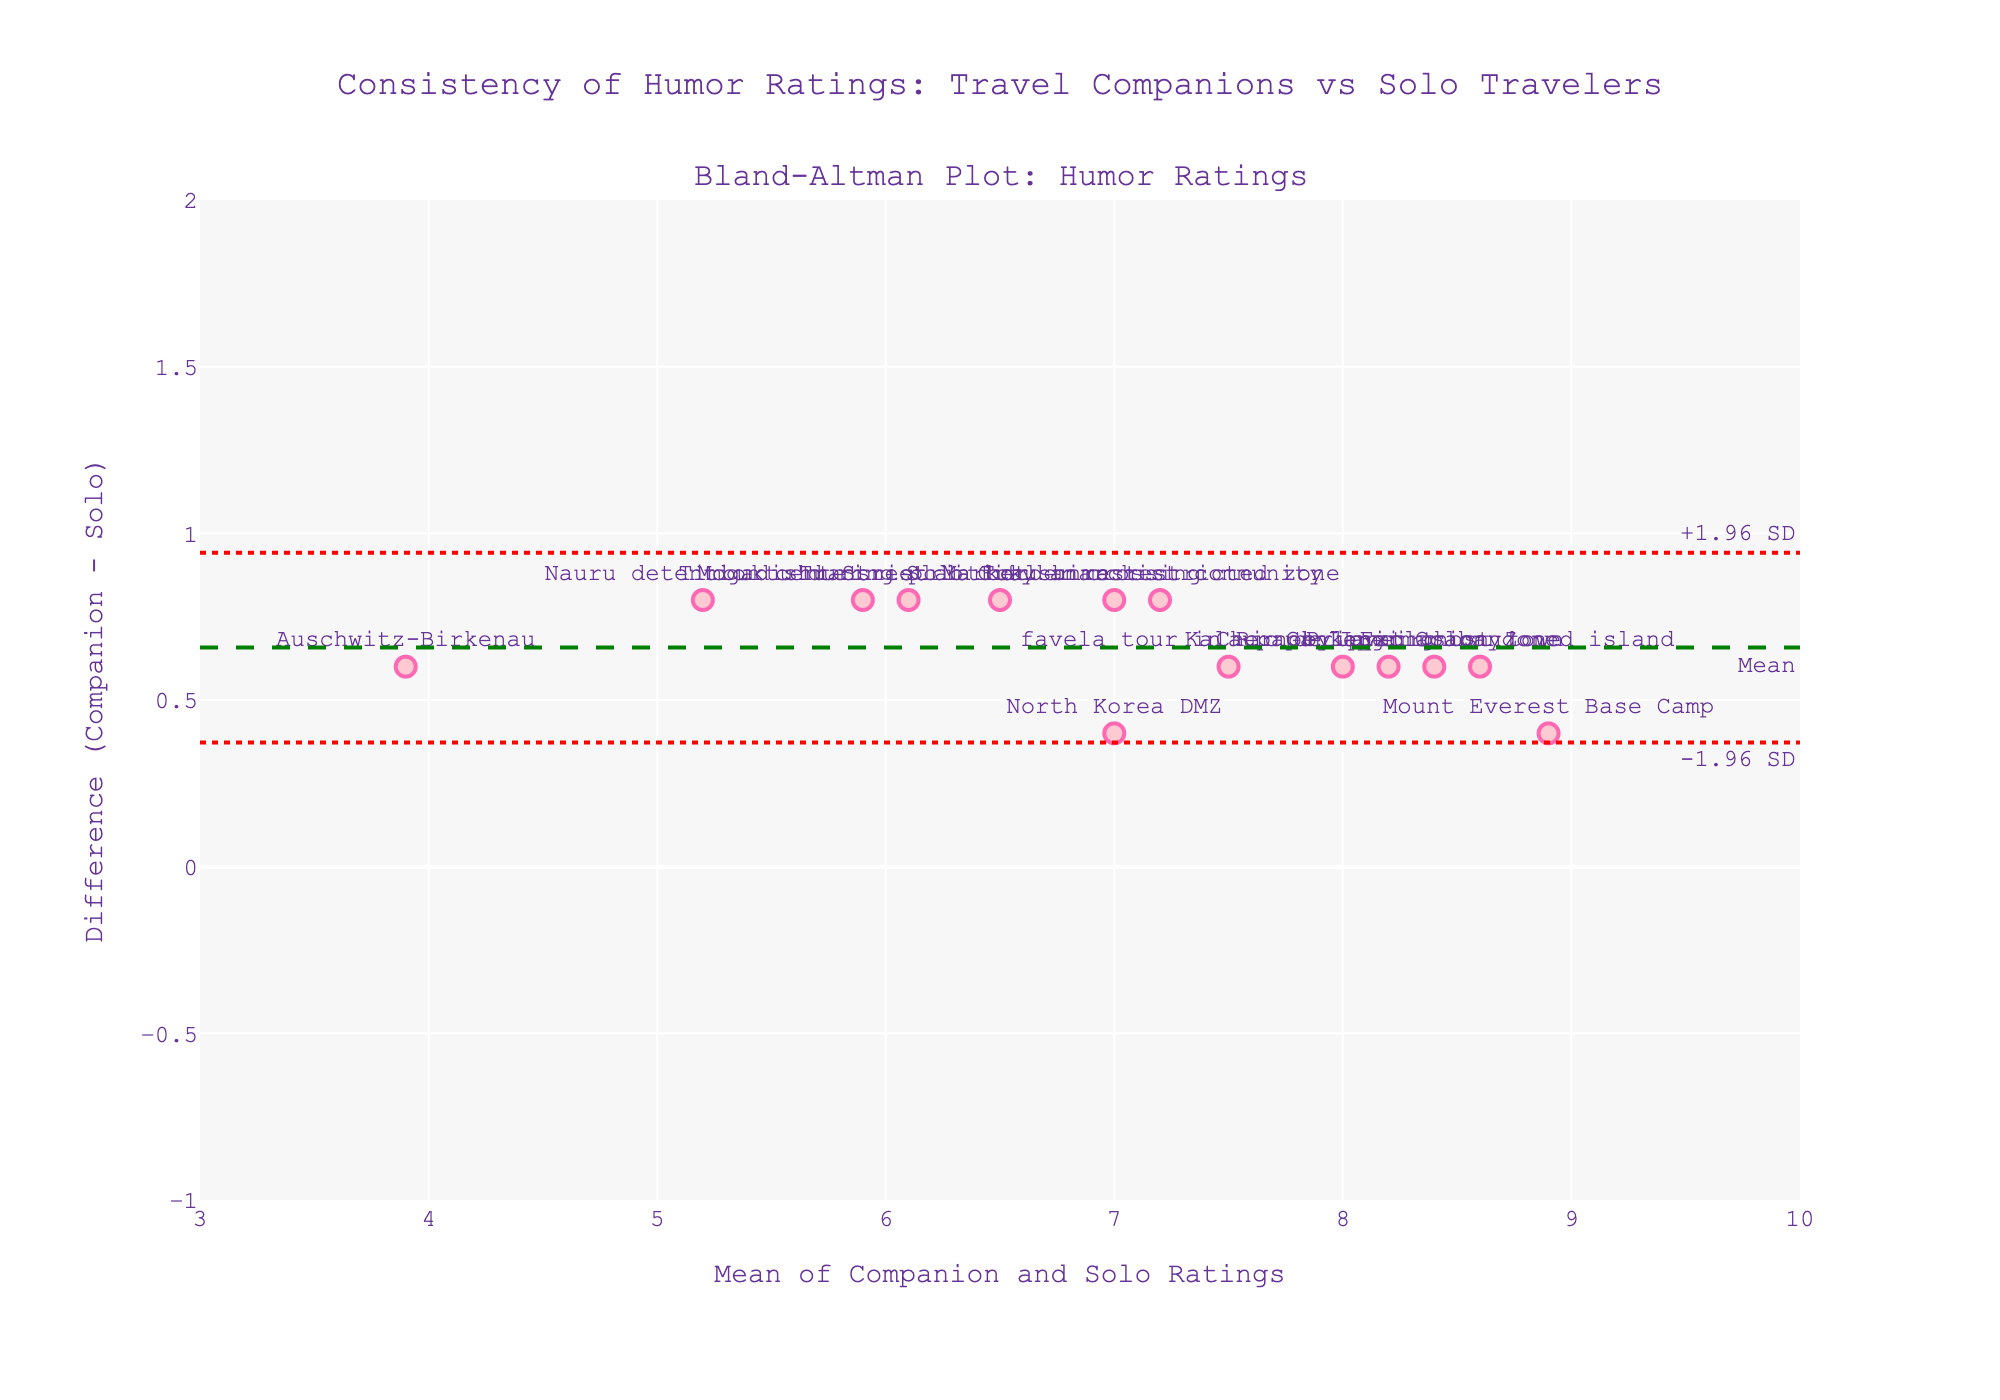what is the title of the figure? The title of the figure is displayed at the top of the plot. It reads "Consistency of Humor Ratings: Travel Companions vs Solo Travelers."
Answer: Consistency of Humor Ratings: Travel Companions vs Solo Travelers How many data points are plotted in the figure? Each marker on the plot represents a data point for a travel destination. By counting the markers, we see there are 14 data points.
Answer: 14 Which travel destination has the largest positive difference in humor ratings between companions and solo travelers? The largest positive difference is identified by the highest y-value on the plot. Checking the y-axis, "Gunkanjima abandoned island" appears to have the largest positive difference at approximately +0.6.
Answer: Gunkanjima abandoned island What are the limits of agreement in the plot? The limits of agreement are represented by the two dotted red lines. The annotations show that they are at approximately -0.19 (lower limit) and +1.27 (upper limit).
Answer: -0.19 and +1.27 Is the mean difference between Companion and Solo Ratings positive or negative? The mean difference is indicated by the green dashed line labeled "Mean." It is positioned above the zero line on the y-axis, indicating a positive mean difference.
Answer: Positive Are there any data points outside the limits of agreement? If so, which one(s)? Data points outside the red dotted lines are outside the limits of agreement. Observing the plot, there's at least one such point: "Auschwitz-Birkenau."
Answer: Auschwitz-Birkenau Which travel destination has a mean rating overall close to 6.5? The mean rating is located on the x-axis. By finding the marker closest to the x-value of 6.5, "Timbuktu during political unrest" matches this condition the best.
Answer: Timbuktu during political unrest What is the average difference in ratings for the destinations with solo ratings below 5? First, identify destinations with solo ratings below 5: “Nauru detention center” and “Auschwitz-Birkenau.” The differences for these are 0.8 and 0.6, respectively. Averaging these, (0.8 + 0.6) / 2 = 0.7.
Answer: 0.7 Which destination has a solo rating of approximately 8.1, and how does its humor rating difference compare to the mean difference? Locate the destination with the solo rating around 8.1, which is "Pripyat ghost town." Its y-value appears to be higher than the mean difference line, suggesting its difference is greater than the mean difference.
Answer: Pripyat ghost town, greater Is there a trend in humor rating differences as the mean rating increases? Observing the Bland-Altman plot, as the mean rating increases along the x-axis, the differences (y-axis) do not show a clear increasing or decreasing trend, indicating no obvious trend.
Answer: No clear trend 